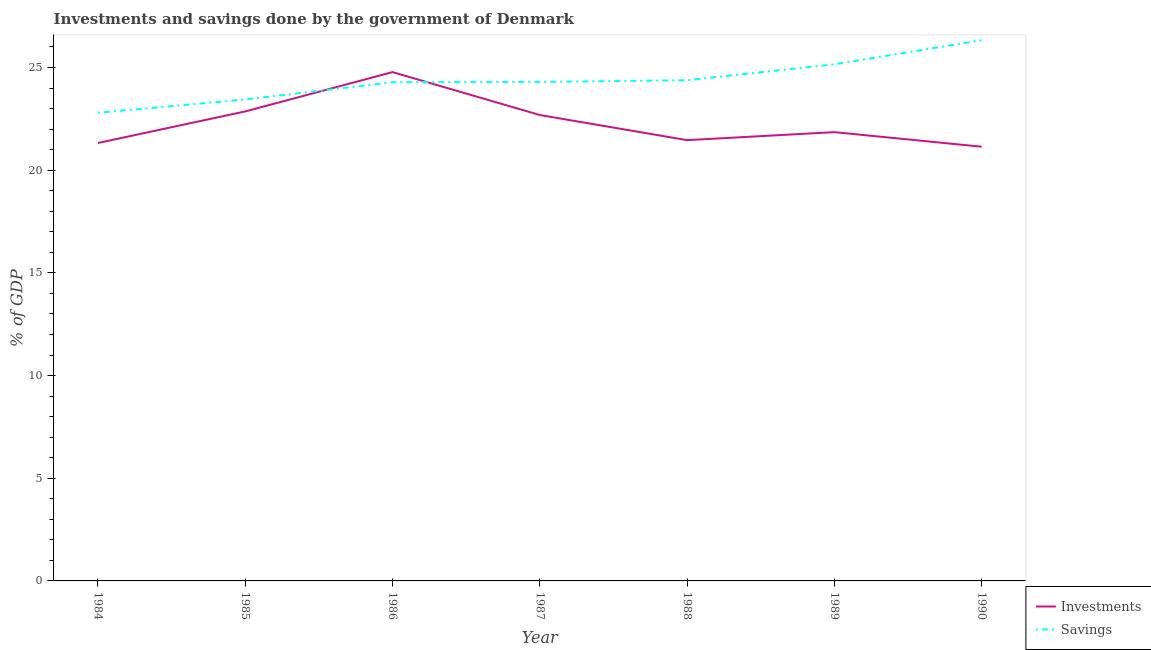How many different coloured lines are there?
Your answer should be compact. 2. Does the line corresponding to investments of government intersect with the line corresponding to savings of government?
Your answer should be very brief. Yes. Is the number of lines equal to the number of legend labels?
Ensure brevity in your answer.  Yes. What is the savings of government in 1990?
Provide a short and direct response. 26.33. Across all years, what is the maximum savings of government?
Provide a short and direct response. 26.33. Across all years, what is the minimum investments of government?
Make the answer very short. 21.14. In which year was the savings of government maximum?
Offer a very short reply. 1990. In which year was the investments of government minimum?
Offer a terse response. 1990. What is the total savings of government in the graph?
Offer a terse response. 170.68. What is the difference between the investments of government in 1984 and that in 1985?
Make the answer very short. -1.54. What is the difference between the investments of government in 1989 and the savings of government in 1988?
Your answer should be compact. -2.53. What is the average savings of government per year?
Provide a short and direct response. 24.38. In the year 1986, what is the difference between the savings of government and investments of government?
Give a very brief answer. -0.49. In how many years, is the savings of government greater than 15 %?
Ensure brevity in your answer.  7. What is the ratio of the investments of government in 1984 to that in 1985?
Your answer should be compact. 0.93. Is the investments of government in 1984 less than that in 1985?
Provide a succinct answer. Yes. Is the difference between the savings of government in 1984 and 1987 greater than the difference between the investments of government in 1984 and 1987?
Your answer should be very brief. No. What is the difference between the highest and the second highest investments of government?
Make the answer very short. 1.91. What is the difference between the highest and the lowest investments of government?
Provide a short and direct response. 3.63. In how many years, is the savings of government greater than the average savings of government taken over all years?
Ensure brevity in your answer.  2. Is the sum of the savings of government in 1984 and 1988 greater than the maximum investments of government across all years?
Offer a very short reply. Yes. Does the investments of government monotonically increase over the years?
Offer a very short reply. No. Is the savings of government strictly greater than the investments of government over the years?
Offer a very short reply. No. How many lines are there?
Give a very brief answer. 2. What is the difference between two consecutive major ticks on the Y-axis?
Ensure brevity in your answer.  5. Are the values on the major ticks of Y-axis written in scientific E-notation?
Give a very brief answer. No. Does the graph contain any zero values?
Offer a terse response. No. How many legend labels are there?
Your answer should be very brief. 2. What is the title of the graph?
Offer a terse response. Investments and savings done by the government of Denmark. Does "Tetanus" appear as one of the legend labels in the graph?
Offer a very short reply. No. What is the label or title of the Y-axis?
Ensure brevity in your answer.  % of GDP. What is the % of GDP of Investments in 1984?
Provide a short and direct response. 21.32. What is the % of GDP of Savings in 1984?
Make the answer very short. 22.8. What is the % of GDP of Investments in 1985?
Provide a short and direct response. 22.86. What is the % of GDP in Savings in 1985?
Your response must be concise. 23.44. What is the % of GDP in Investments in 1986?
Ensure brevity in your answer.  24.77. What is the % of GDP in Savings in 1986?
Your response must be concise. 24.28. What is the % of GDP in Investments in 1987?
Your response must be concise. 22.69. What is the % of GDP in Savings in 1987?
Offer a terse response. 24.3. What is the % of GDP of Investments in 1988?
Offer a very short reply. 21.46. What is the % of GDP in Savings in 1988?
Your answer should be very brief. 24.38. What is the % of GDP of Investments in 1989?
Give a very brief answer. 21.85. What is the % of GDP of Savings in 1989?
Make the answer very short. 25.15. What is the % of GDP of Investments in 1990?
Your response must be concise. 21.14. What is the % of GDP of Savings in 1990?
Make the answer very short. 26.33. Across all years, what is the maximum % of GDP in Investments?
Offer a terse response. 24.77. Across all years, what is the maximum % of GDP of Savings?
Keep it short and to the point. 26.33. Across all years, what is the minimum % of GDP of Investments?
Your response must be concise. 21.14. Across all years, what is the minimum % of GDP of Savings?
Offer a terse response. 22.8. What is the total % of GDP in Investments in the graph?
Ensure brevity in your answer.  156.1. What is the total % of GDP in Savings in the graph?
Provide a short and direct response. 170.68. What is the difference between the % of GDP of Investments in 1984 and that in 1985?
Give a very brief answer. -1.54. What is the difference between the % of GDP in Savings in 1984 and that in 1985?
Keep it short and to the point. -0.64. What is the difference between the % of GDP in Investments in 1984 and that in 1986?
Ensure brevity in your answer.  -3.45. What is the difference between the % of GDP of Savings in 1984 and that in 1986?
Your answer should be very brief. -1.49. What is the difference between the % of GDP of Investments in 1984 and that in 1987?
Provide a succinct answer. -1.36. What is the difference between the % of GDP in Savings in 1984 and that in 1987?
Make the answer very short. -1.5. What is the difference between the % of GDP of Investments in 1984 and that in 1988?
Offer a very short reply. -0.14. What is the difference between the % of GDP of Savings in 1984 and that in 1988?
Your response must be concise. -1.58. What is the difference between the % of GDP in Investments in 1984 and that in 1989?
Keep it short and to the point. -0.53. What is the difference between the % of GDP of Savings in 1984 and that in 1989?
Provide a short and direct response. -2.36. What is the difference between the % of GDP of Investments in 1984 and that in 1990?
Provide a short and direct response. 0.18. What is the difference between the % of GDP in Savings in 1984 and that in 1990?
Your response must be concise. -3.53. What is the difference between the % of GDP in Investments in 1985 and that in 1986?
Your response must be concise. -1.91. What is the difference between the % of GDP in Savings in 1985 and that in 1986?
Provide a succinct answer. -0.84. What is the difference between the % of GDP of Investments in 1985 and that in 1987?
Your answer should be compact. 0.17. What is the difference between the % of GDP of Savings in 1985 and that in 1987?
Provide a succinct answer. -0.86. What is the difference between the % of GDP in Investments in 1985 and that in 1988?
Your answer should be very brief. 1.4. What is the difference between the % of GDP of Savings in 1985 and that in 1988?
Keep it short and to the point. -0.94. What is the difference between the % of GDP of Investments in 1985 and that in 1989?
Provide a short and direct response. 1.01. What is the difference between the % of GDP of Savings in 1985 and that in 1989?
Your answer should be compact. -1.71. What is the difference between the % of GDP in Investments in 1985 and that in 1990?
Give a very brief answer. 1.72. What is the difference between the % of GDP of Savings in 1985 and that in 1990?
Offer a very short reply. -2.89. What is the difference between the % of GDP in Investments in 1986 and that in 1987?
Your response must be concise. 2.09. What is the difference between the % of GDP in Savings in 1986 and that in 1987?
Provide a short and direct response. -0.02. What is the difference between the % of GDP in Investments in 1986 and that in 1988?
Ensure brevity in your answer.  3.31. What is the difference between the % of GDP in Savings in 1986 and that in 1988?
Give a very brief answer. -0.1. What is the difference between the % of GDP in Investments in 1986 and that in 1989?
Your response must be concise. 2.92. What is the difference between the % of GDP in Savings in 1986 and that in 1989?
Make the answer very short. -0.87. What is the difference between the % of GDP of Investments in 1986 and that in 1990?
Your answer should be very brief. 3.63. What is the difference between the % of GDP of Savings in 1986 and that in 1990?
Ensure brevity in your answer.  -2.05. What is the difference between the % of GDP in Investments in 1987 and that in 1988?
Your response must be concise. 1.22. What is the difference between the % of GDP in Savings in 1987 and that in 1988?
Make the answer very short. -0.08. What is the difference between the % of GDP of Investments in 1987 and that in 1989?
Offer a very short reply. 0.83. What is the difference between the % of GDP in Savings in 1987 and that in 1989?
Offer a terse response. -0.86. What is the difference between the % of GDP in Investments in 1987 and that in 1990?
Keep it short and to the point. 1.54. What is the difference between the % of GDP in Savings in 1987 and that in 1990?
Ensure brevity in your answer.  -2.03. What is the difference between the % of GDP in Investments in 1988 and that in 1989?
Give a very brief answer. -0.39. What is the difference between the % of GDP in Savings in 1988 and that in 1989?
Provide a short and direct response. -0.78. What is the difference between the % of GDP of Investments in 1988 and that in 1990?
Provide a succinct answer. 0.32. What is the difference between the % of GDP in Savings in 1988 and that in 1990?
Your response must be concise. -1.95. What is the difference between the % of GDP of Investments in 1989 and that in 1990?
Provide a succinct answer. 0.71. What is the difference between the % of GDP in Savings in 1989 and that in 1990?
Provide a succinct answer. -1.17. What is the difference between the % of GDP in Investments in 1984 and the % of GDP in Savings in 1985?
Ensure brevity in your answer.  -2.12. What is the difference between the % of GDP of Investments in 1984 and the % of GDP of Savings in 1986?
Ensure brevity in your answer.  -2.96. What is the difference between the % of GDP of Investments in 1984 and the % of GDP of Savings in 1987?
Ensure brevity in your answer.  -2.98. What is the difference between the % of GDP in Investments in 1984 and the % of GDP in Savings in 1988?
Offer a terse response. -3.06. What is the difference between the % of GDP in Investments in 1984 and the % of GDP in Savings in 1989?
Offer a terse response. -3.83. What is the difference between the % of GDP in Investments in 1984 and the % of GDP in Savings in 1990?
Your answer should be very brief. -5.01. What is the difference between the % of GDP of Investments in 1985 and the % of GDP of Savings in 1986?
Provide a succinct answer. -1.42. What is the difference between the % of GDP in Investments in 1985 and the % of GDP in Savings in 1987?
Make the answer very short. -1.44. What is the difference between the % of GDP in Investments in 1985 and the % of GDP in Savings in 1988?
Your answer should be very brief. -1.52. What is the difference between the % of GDP of Investments in 1985 and the % of GDP of Savings in 1989?
Make the answer very short. -2.29. What is the difference between the % of GDP in Investments in 1985 and the % of GDP in Savings in 1990?
Your answer should be compact. -3.47. What is the difference between the % of GDP of Investments in 1986 and the % of GDP of Savings in 1987?
Provide a short and direct response. 0.48. What is the difference between the % of GDP of Investments in 1986 and the % of GDP of Savings in 1988?
Ensure brevity in your answer.  0.4. What is the difference between the % of GDP of Investments in 1986 and the % of GDP of Savings in 1989?
Offer a terse response. -0.38. What is the difference between the % of GDP in Investments in 1986 and the % of GDP in Savings in 1990?
Provide a succinct answer. -1.55. What is the difference between the % of GDP in Investments in 1987 and the % of GDP in Savings in 1988?
Provide a succinct answer. -1.69. What is the difference between the % of GDP of Investments in 1987 and the % of GDP of Savings in 1989?
Offer a very short reply. -2.47. What is the difference between the % of GDP of Investments in 1987 and the % of GDP of Savings in 1990?
Your answer should be very brief. -3.64. What is the difference between the % of GDP of Investments in 1988 and the % of GDP of Savings in 1989?
Keep it short and to the point. -3.69. What is the difference between the % of GDP in Investments in 1988 and the % of GDP in Savings in 1990?
Make the answer very short. -4.87. What is the difference between the % of GDP in Investments in 1989 and the % of GDP in Savings in 1990?
Offer a terse response. -4.48. What is the average % of GDP in Investments per year?
Make the answer very short. 22.3. What is the average % of GDP in Savings per year?
Give a very brief answer. 24.38. In the year 1984, what is the difference between the % of GDP of Investments and % of GDP of Savings?
Offer a very short reply. -1.47. In the year 1985, what is the difference between the % of GDP in Investments and % of GDP in Savings?
Provide a succinct answer. -0.58. In the year 1986, what is the difference between the % of GDP of Investments and % of GDP of Savings?
Provide a short and direct response. 0.49. In the year 1987, what is the difference between the % of GDP in Investments and % of GDP in Savings?
Make the answer very short. -1.61. In the year 1988, what is the difference between the % of GDP in Investments and % of GDP in Savings?
Make the answer very short. -2.92. In the year 1989, what is the difference between the % of GDP in Investments and % of GDP in Savings?
Give a very brief answer. -3.3. In the year 1990, what is the difference between the % of GDP in Investments and % of GDP in Savings?
Give a very brief answer. -5.19. What is the ratio of the % of GDP of Investments in 1984 to that in 1985?
Provide a succinct answer. 0.93. What is the ratio of the % of GDP in Savings in 1984 to that in 1985?
Provide a succinct answer. 0.97. What is the ratio of the % of GDP of Investments in 1984 to that in 1986?
Your response must be concise. 0.86. What is the ratio of the % of GDP of Savings in 1984 to that in 1986?
Keep it short and to the point. 0.94. What is the ratio of the % of GDP of Investments in 1984 to that in 1987?
Your answer should be very brief. 0.94. What is the ratio of the % of GDP of Savings in 1984 to that in 1987?
Keep it short and to the point. 0.94. What is the ratio of the % of GDP of Savings in 1984 to that in 1988?
Provide a short and direct response. 0.94. What is the ratio of the % of GDP in Investments in 1984 to that in 1989?
Offer a terse response. 0.98. What is the ratio of the % of GDP of Savings in 1984 to that in 1989?
Ensure brevity in your answer.  0.91. What is the ratio of the % of GDP in Investments in 1984 to that in 1990?
Make the answer very short. 1.01. What is the ratio of the % of GDP of Savings in 1984 to that in 1990?
Your answer should be very brief. 0.87. What is the ratio of the % of GDP in Investments in 1985 to that in 1986?
Your response must be concise. 0.92. What is the ratio of the % of GDP of Savings in 1985 to that in 1986?
Your response must be concise. 0.97. What is the ratio of the % of GDP in Investments in 1985 to that in 1987?
Provide a short and direct response. 1.01. What is the ratio of the % of GDP in Savings in 1985 to that in 1987?
Ensure brevity in your answer.  0.96. What is the ratio of the % of GDP of Investments in 1985 to that in 1988?
Make the answer very short. 1.07. What is the ratio of the % of GDP in Savings in 1985 to that in 1988?
Your response must be concise. 0.96. What is the ratio of the % of GDP of Investments in 1985 to that in 1989?
Your answer should be very brief. 1.05. What is the ratio of the % of GDP in Savings in 1985 to that in 1989?
Keep it short and to the point. 0.93. What is the ratio of the % of GDP of Investments in 1985 to that in 1990?
Keep it short and to the point. 1.08. What is the ratio of the % of GDP in Savings in 1985 to that in 1990?
Keep it short and to the point. 0.89. What is the ratio of the % of GDP of Investments in 1986 to that in 1987?
Offer a terse response. 1.09. What is the ratio of the % of GDP of Savings in 1986 to that in 1987?
Provide a succinct answer. 1. What is the ratio of the % of GDP in Investments in 1986 to that in 1988?
Provide a short and direct response. 1.15. What is the ratio of the % of GDP of Savings in 1986 to that in 1988?
Provide a short and direct response. 1. What is the ratio of the % of GDP of Investments in 1986 to that in 1989?
Your response must be concise. 1.13. What is the ratio of the % of GDP in Savings in 1986 to that in 1989?
Your answer should be very brief. 0.97. What is the ratio of the % of GDP of Investments in 1986 to that in 1990?
Your response must be concise. 1.17. What is the ratio of the % of GDP of Savings in 1986 to that in 1990?
Keep it short and to the point. 0.92. What is the ratio of the % of GDP in Investments in 1987 to that in 1988?
Offer a very short reply. 1.06. What is the ratio of the % of GDP in Savings in 1987 to that in 1988?
Your response must be concise. 1. What is the ratio of the % of GDP in Investments in 1987 to that in 1989?
Offer a terse response. 1.04. What is the ratio of the % of GDP in Savings in 1987 to that in 1989?
Keep it short and to the point. 0.97. What is the ratio of the % of GDP of Investments in 1987 to that in 1990?
Give a very brief answer. 1.07. What is the ratio of the % of GDP of Savings in 1987 to that in 1990?
Give a very brief answer. 0.92. What is the ratio of the % of GDP of Investments in 1988 to that in 1989?
Give a very brief answer. 0.98. What is the ratio of the % of GDP in Savings in 1988 to that in 1989?
Your response must be concise. 0.97. What is the ratio of the % of GDP in Investments in 1988 to that in 1990?
Offer a terse response. 1.02. What is the ratio of the % of GDP in Savings in 1988 to that in 1990?
Give a very brief answer. 0.93. What is the ratio of the % of GDP in Investments in 1989 to that in 1990?
Your answer should be compact. 1.03. What is the ratio of the % of GDP of Savings in 1989 to that in 1990?
Make the answer very short. 0.96. What is the difference between the highest and the second highest % of GDP of Investments?
Provide a succinct answer. 1.91. What is the difference between the highest and the second highest % of GDP of Savings?
Offer a terse response. 1.17. What is the difference between the highest and the lowest % of GDP in Investments?
Your answer should be very brief. 3.63. What is the difference between the highest and the lowest % of GDP in Savings?
Provide a short and direct response. 3.53. 